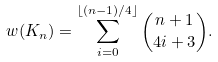Convert formula to latex. <formula><loc_0><loc_0><loc_500><loc_500>w ( K _ { n } ) = \sum _ { i = 0 } ^ { \lfloor ( n - 1 ) / 4 \rfloor } \binom { n + 1 } { 4 i + 3 } .</formula> 